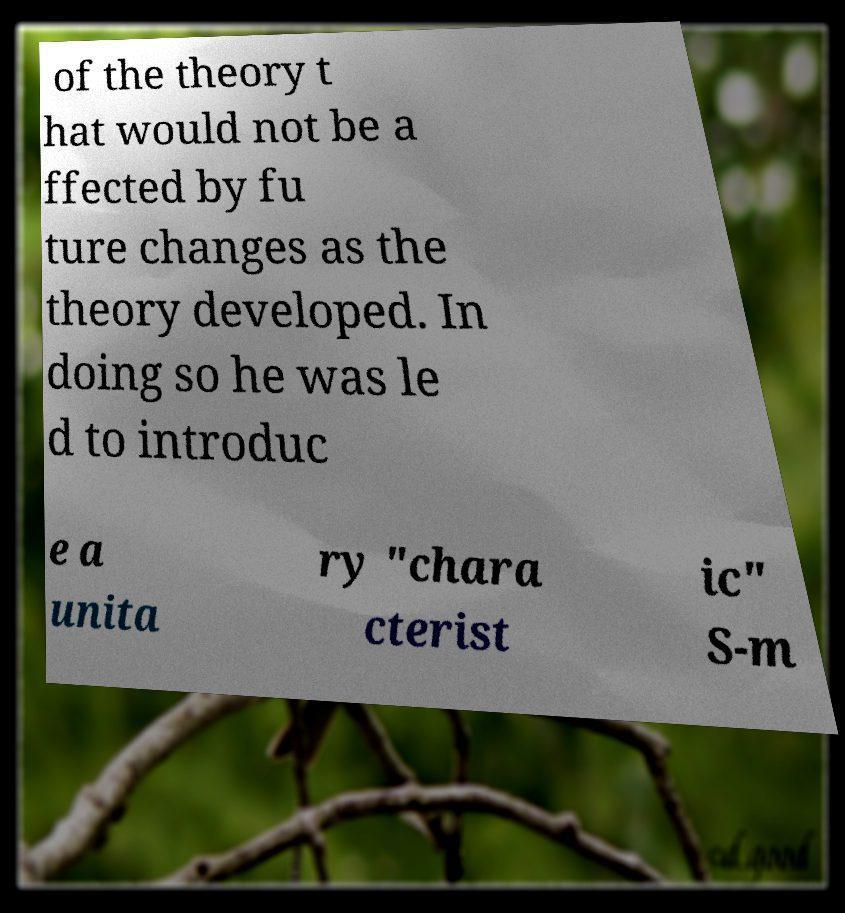What messages or text are displayed in this image? I need them in a readable, typed format. of the theory t hat would not be a ffected by fu ture changes as the theory developed. In doing so he was le d to introduc e a unita ry "chara cterist ic" S-m 